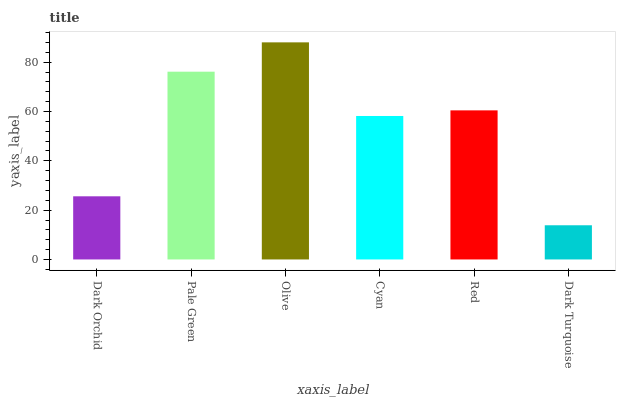Is Dark Turquoise the minimum?
Answer yes or no. Yes. Is Olive the maximum?
Answer yes or no. Yes. Is Pale Green the minimum?
Answer yes or no. No. Is Pale Green the maximum?
Answer yes or no. No. Is Pale Green greater than Dark Orchid?
Answer yes or no. Yes. Is Dark Orchid less than Pale Green?
Answer yes or no. Yes. Is Dark Orchid greater than Pale Green?
Answer yes or no. No. Is Pale Green less than Dark Orchid?
Answer yes or no. No. Is Red the high median?
Answer yes or no. Yes. Is Cyan the low median?
Answer yes or no. Yes. Is Pale Green the high median?
Answer yes or no. No. Is Olive the low median?
Answer yes or no. No. 